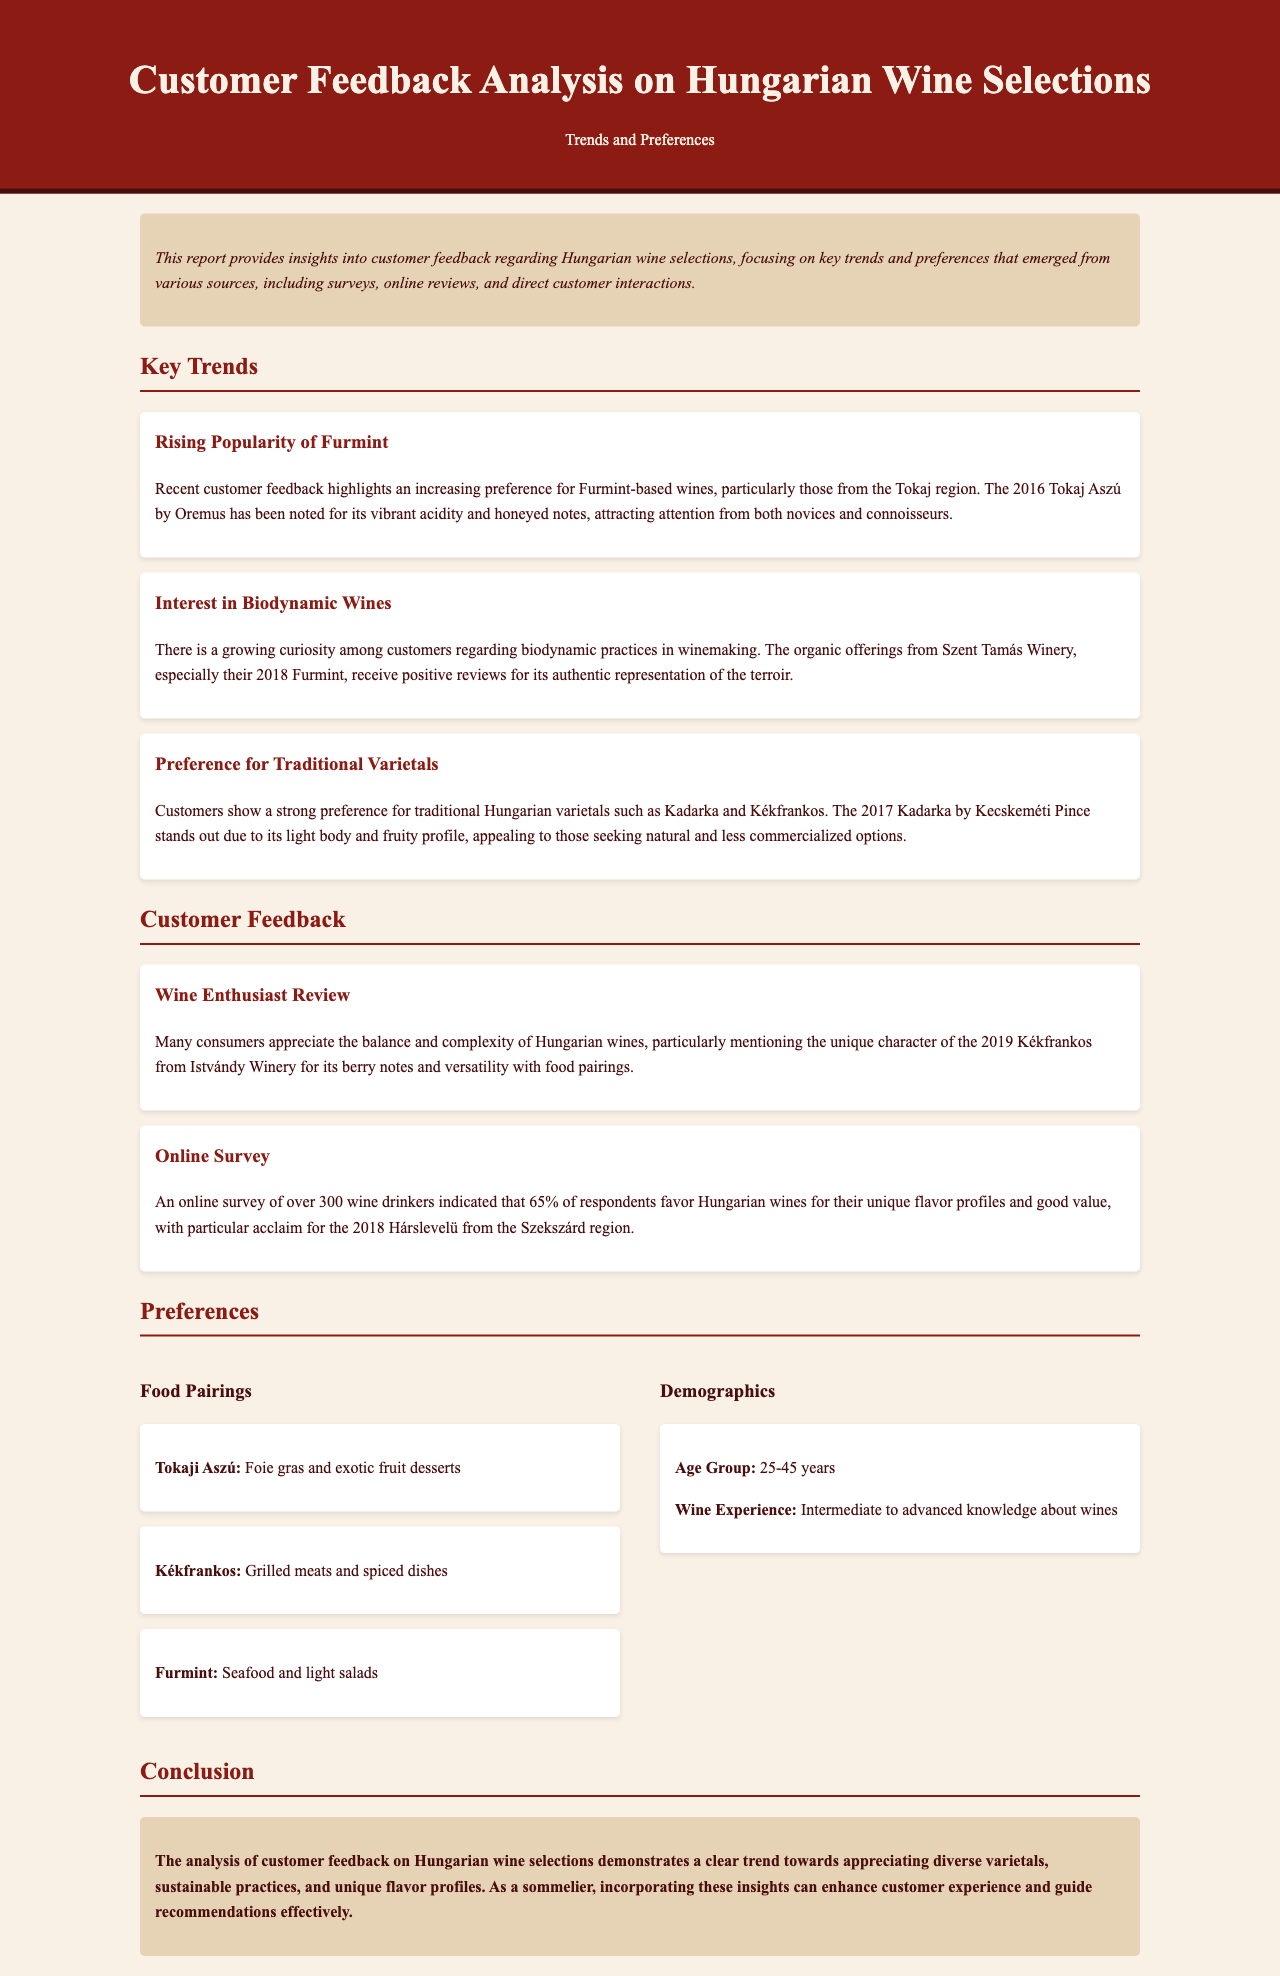What is the rising popular Hungarian wine varietal mentioned? The document specifically highlights an increasing preference for Furmint-based wines.
Answer: Furmint Which winery is noted for the 2016 Tokaj Aszú? The document identifies Oremus as the winery associated with the 2016 Tokaj Aszú.
Answer: Oremus What percentage of online survey respondents favor Hungarian wines for unique flavor profiles? An online survey indicated that 65% of respondents favor Hungarian wines for their unique flavor profiles.
Answer: 65% What type of wine does the 2017 Kadarka by Kecskeméti Pince represent? The document states that the 2017 Kadarka is a traditional Hungarian varietal, specifically Kadarka.
Answer: Kadarka Which food pairing is recommended for Tokaji Aszú? The document recommends foie gras and exotic fruit desserts as a food pairing for Tokaji Aszú.
Answer: Foie gras and exotic fruit desserts What demographic age group is indicated to favor Hungarian wines? The document mentions that the favored age group for Hungarian wines is 25-45 years.
Answer: 25-45 years Which type of wine receives positive reviews for its representation of the terroir? The document mentions that the organic offerings from Szent Tamás Winery, particularly their 2018 Furmint, receive positive reviews.
Answer: 2018 Furmint What is highlighted as a key customer preference trend in this report? A key preference trend highlighted is customers' strong preference for traditional Hungarian varietals like Kadarka and Kékfrankos.
Answer: Traditional Hungarian varietals Who has reviewed the unique character of the 2019 Kékfrankos? The document describes a "Wine Enthusiast Review" regarding the unique character of the 2019 Kékfrankos.
Answer: Wine Enthusiast Review 